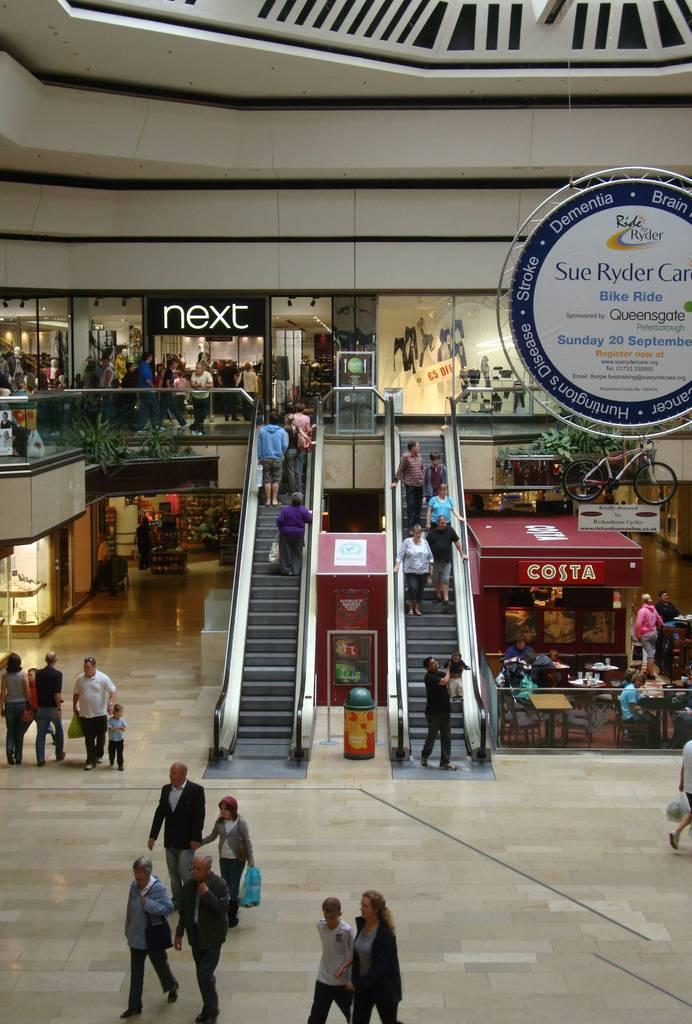Can you describe this image briefly? There are groups of people walking. These are the escalators. I can see few people standing. These are the shops on the name boards. Here is a bicycle. This looks like a hoarding, which is hanging to the roof. I think these are the kind of house plants. 